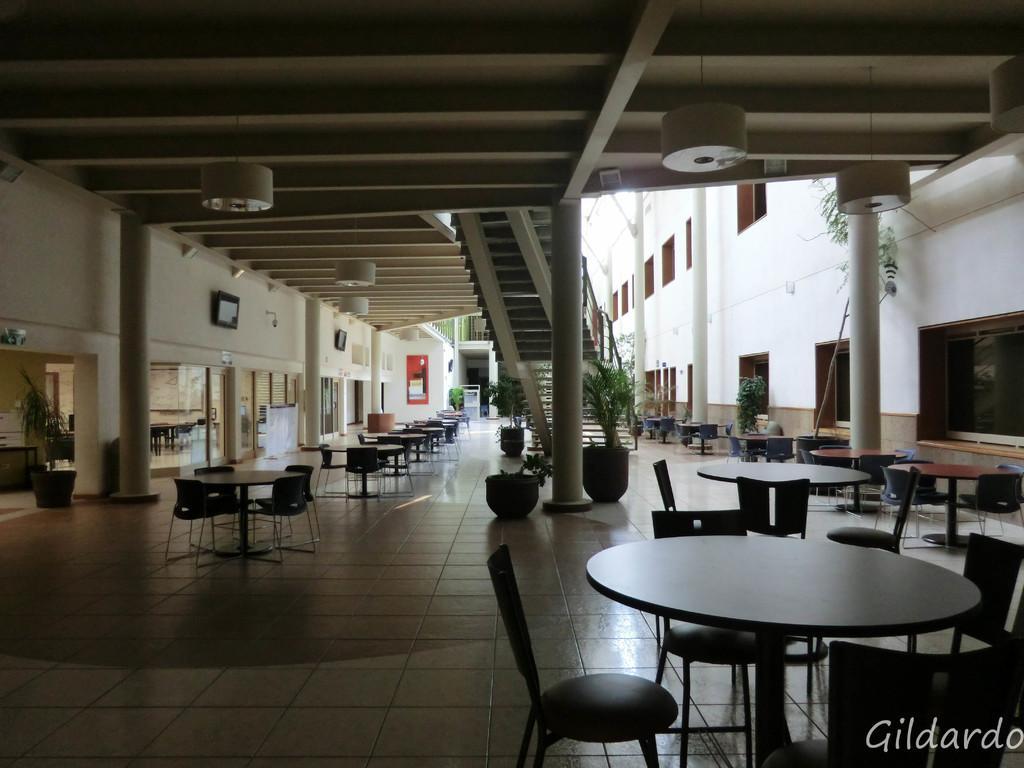Could you give a brief overview of what you see in this image? In this image we can see some tables, chairs, windows, house plants, staircase, there is a poster, there are some photo frames on the wall. 